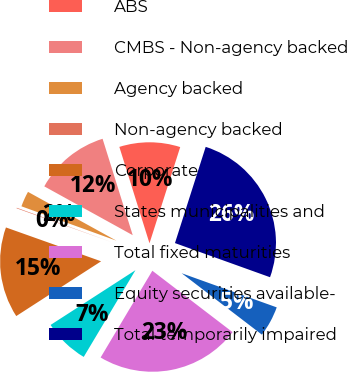Convert chart. <chart><loc_0><loc_0><loc_500><loc_500><pie_chart><fcel>ABS<fcel>CMBS - Non-agency backed<fcel>Agency backed<fcel>Non-agency backed<fcel>Corporate<fcel>States municipalities and<fcel>Total fixed maturities<fcel>Equity securities available-<fcel>Total temporarily impaired<nl><fcel>9.74%<fcel>12.15%<fcel>2.5%<fcel>0.09%<fcel>14.56%<fcel>7.32%<fcel>23.16%<fcel>4.91%<fcel>25.57%<nl></chart> 